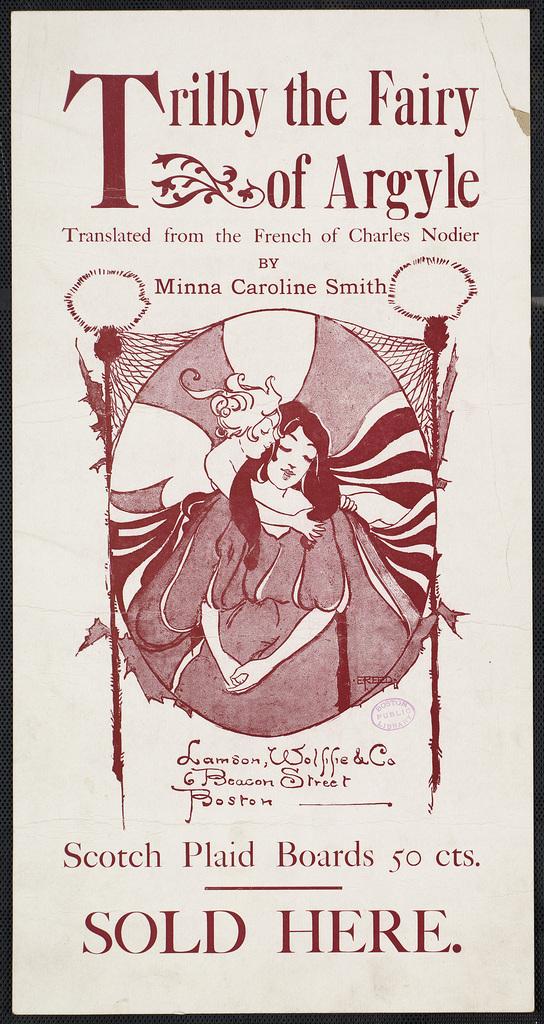What is the name of the show?
Your answer should be compact. Trilby the fairy of argyle. What is sold here?
Offer a very short reply. Scotch plaid boards. 